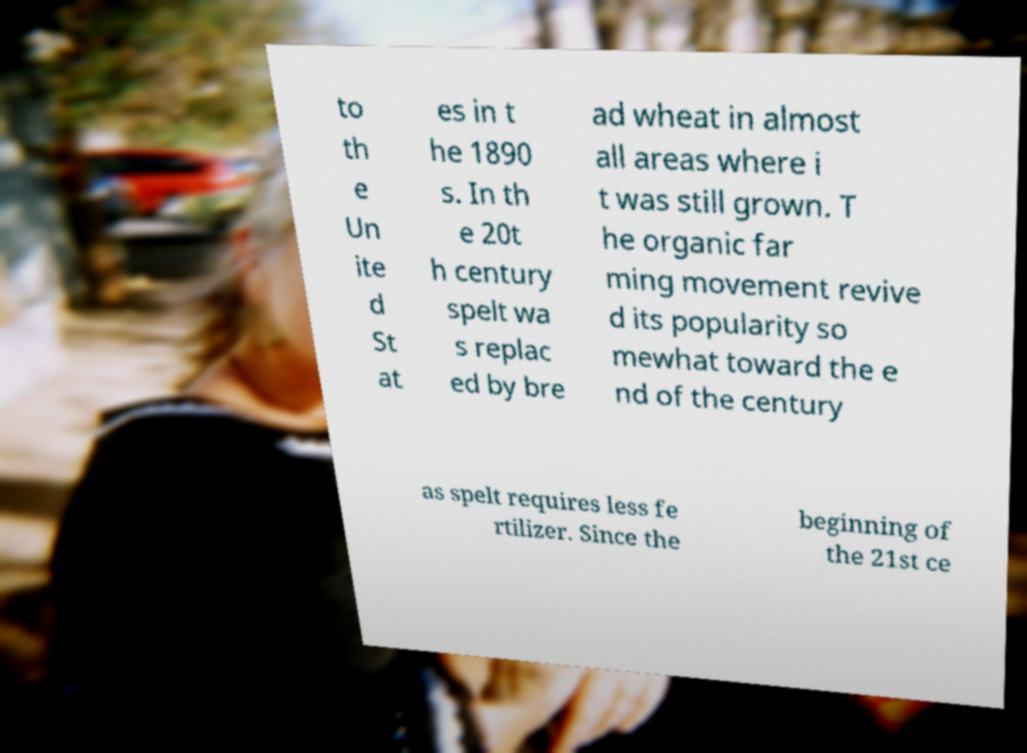There's text embedded in this image that I need extracted. Can you transcribe it verbatim? to th e Un ite d St at es in t he 1890 s. In th e 20t h century spelt wa s replac ed by bre ad wheat in almost all areas where i t was still grown. T he organic far ming movement revive d its popularity so mewhat toward the e nd of the century as spelt requires less fe rtilizer. Since the beginning of the 21st ce 